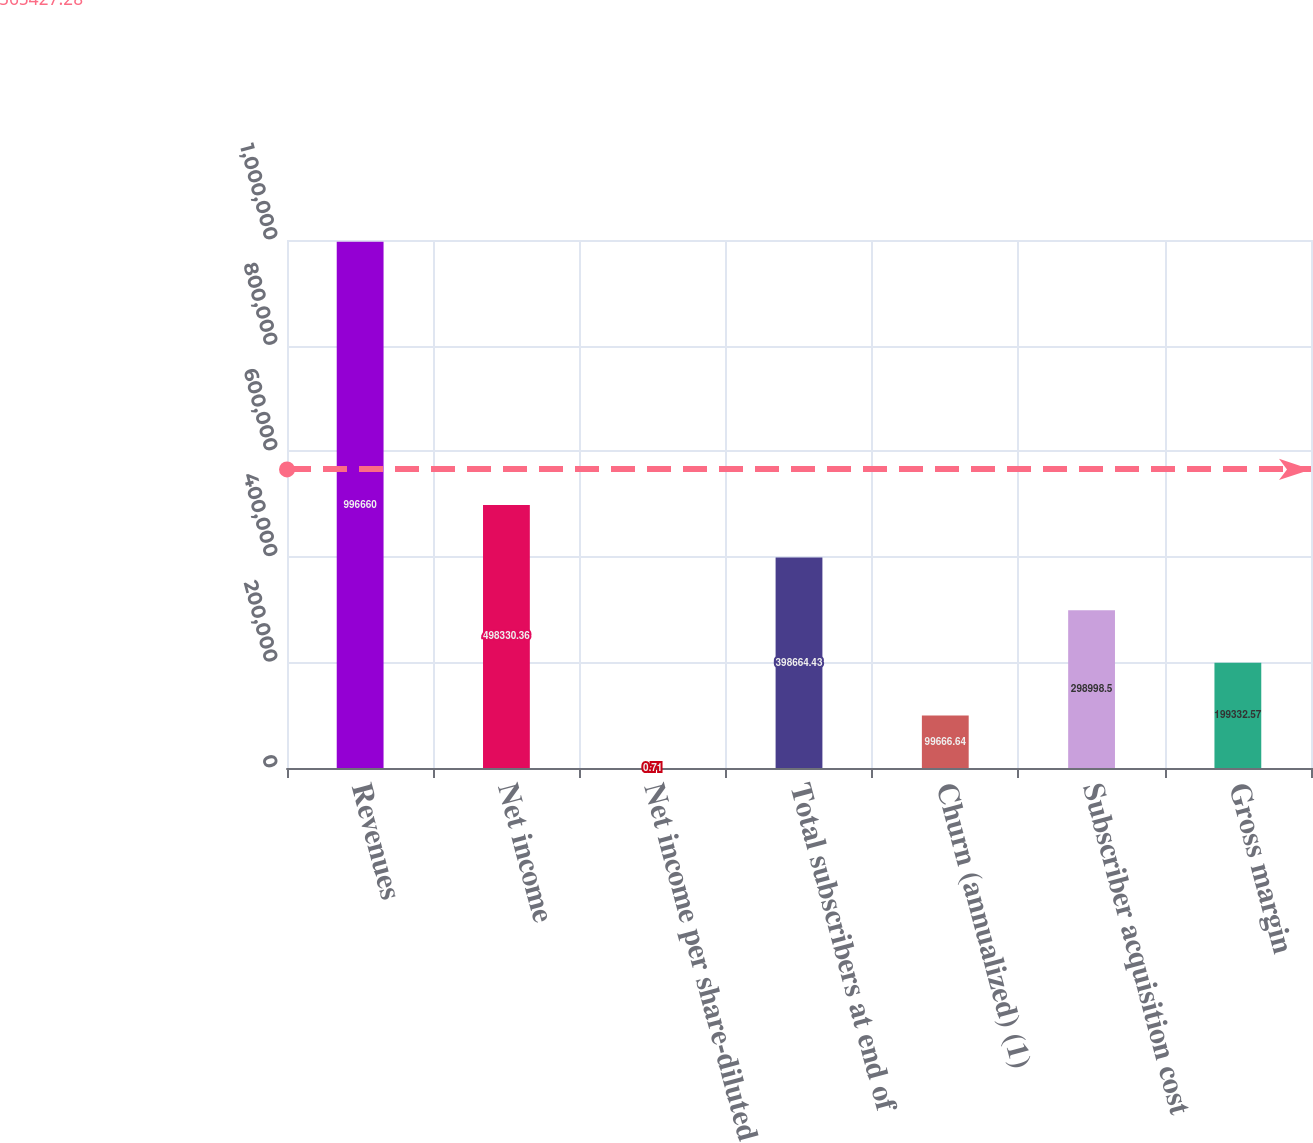Convert chart. <chart><loc_0><loc_0><loc_500><loc_500><bar_chart><fcel>Revenues<fcel>Net income<fcel>Net income per share-diluted<fcel>Total subscribers at end of<fcel>Churn (annualized) (1)<fcel>Subscriber acquisition cost<fcel>Gross margin<nl><fcel>996660<fcel>498330<fcel>0.71<fcel>398664<fcel>99666.6<fcel>298998<fcel>199333<nl></chart> 